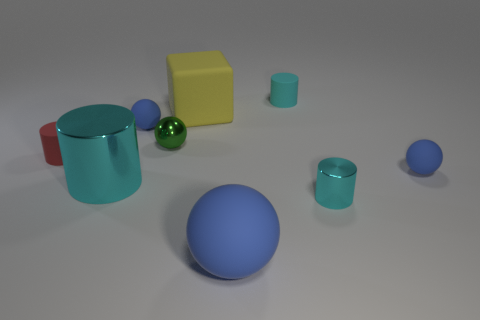Subtract all blue spheres. How many were subtracted if there are1blue spheres left? 2 Subtract all cyan balls. How many cyan cylinders are left? 3 Subtract 1 cylinders. How many cylinders are left? 3 Add 1 small blue rubber things. How many objects exist? 10 Subtract all cylinders. How many objects are left? 5 Subtract 0 brown cubes. How many objects are left? 9 Subtract all balls. Subtract all blue things. How many objects are left? 2 Add 2 small red matte things. How many small red matte things are left? 3 Add 1 small green balls. How many small green balls exist? 2 